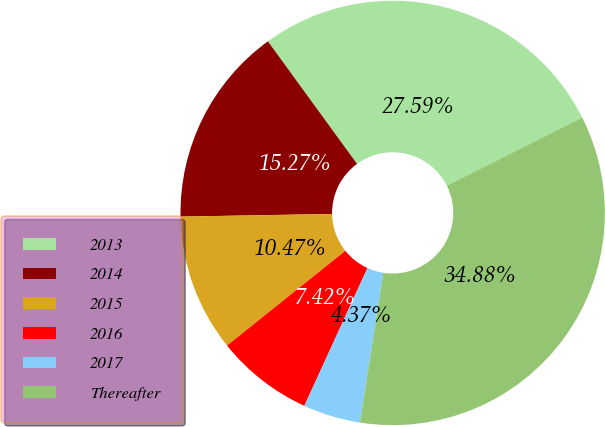Convert chart. <chart><loc_0><loc_0><loc_500><loc_500><pie_chart><fcel>2013<fcel>2014<fcel>2015<fcel>2016<fcel>2017<fcel>Thereafter<nl><fcel>27.59%<fcel>15.27%<fcel>10.47%<fcel>7.42%<fcel>4.37%<fcel>34.88%<nl></chart> 